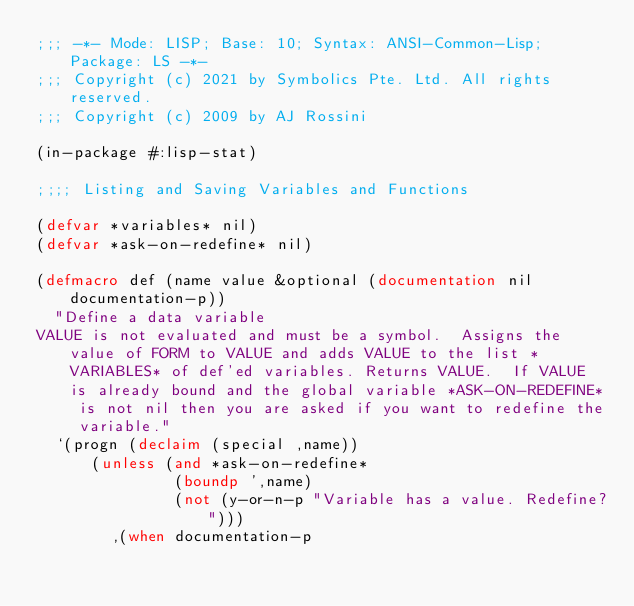<code> <loc_0><loc_0><loc_500><loc_500><_Lisp_>;;; -*- Mode: LISP; Base: 10; Syntax: ANSI-Common-Lisp; Package: LS -*-
;;; Copyright (c) 2021 by Symbolics Pte. Ltd. All rights reserved.
;;; Copyright (c) 2009 by AJ Rossini

(in-package #:lisp-stat)

;;;; Listing and Saving Variables and Functions

(defvar *variables* nil)
(defvar *ask-on-redefine* nil)

(defmacro def (name value &optional (documentation nil documentation-p))
  "Define a data variable
VALUE is not evaluated and must be a symbol.  Assigns the value of FORM to VALUE and adds VALUE to the list *VARIABLES* of def'ed variables. Returns VALUE.  If VALUE is already bound and the global variable *ASK-ON-REDEFINE* is not nil then you are asked if you want to redefine the variable."
  `(progn (declaim (special ,name))
	  (unless (and *ask-on-redefine*
		       (boundp ',name)
		       (not (y-or-n-p "Variable has a value. Redefine?")))
	    ,(when documentation-p</code> 